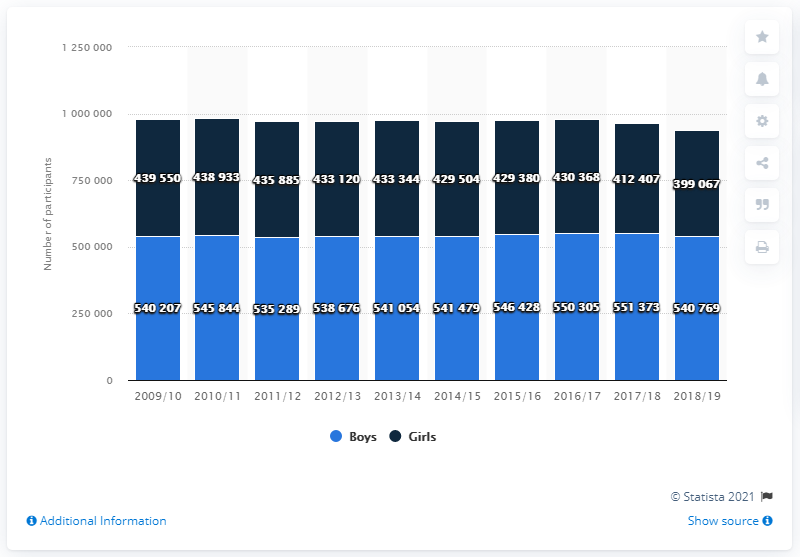Outline some significant characteristics in this image. During the 2018/19 high school basketball season, a total of 540,769 boys participated in the sport. 